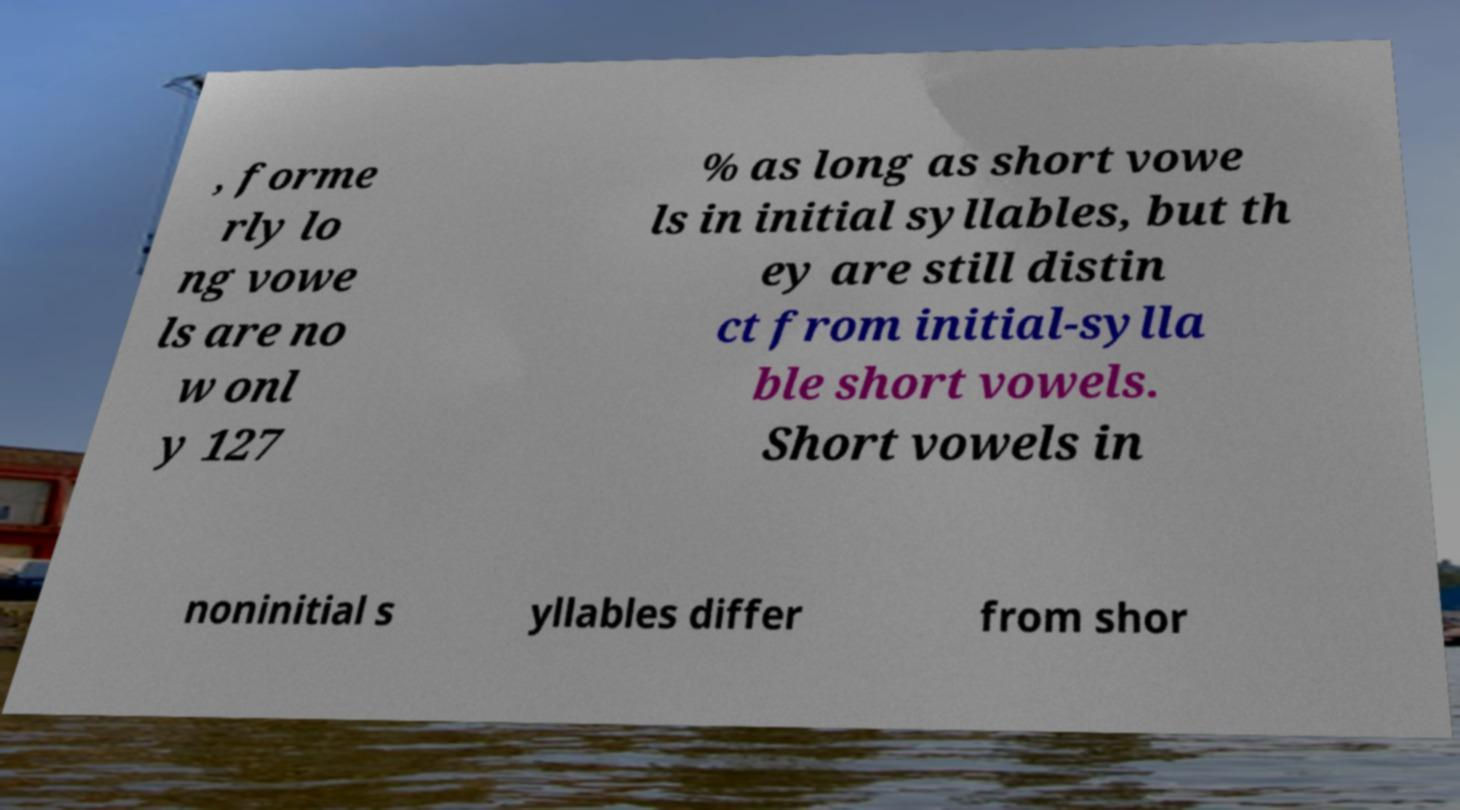Please identify and transcribe the text found in this image. , forme rly lo ng vowe ls are no w onl y 127 % as long as short vowe ls in initial syllables, but th ey are still distin ct from initial-sylla ble short vowels. Short vowels in noninitial s yllables differ from shor 